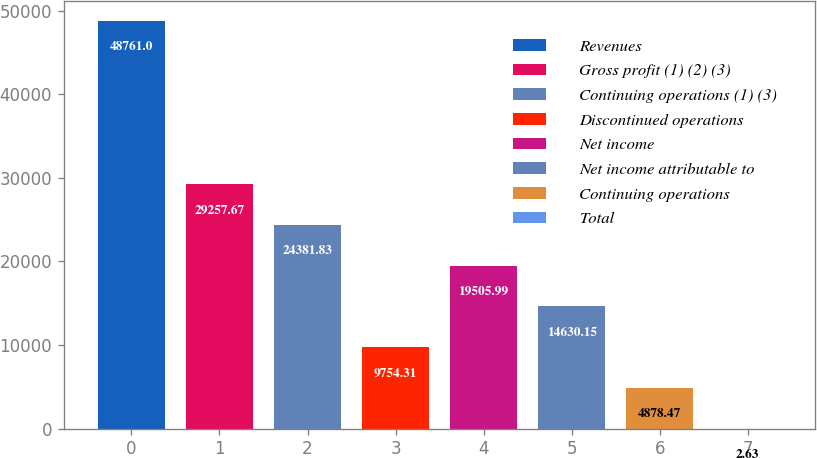<chart> <loc_0><loc_0><loc_500><loc_500><bar_chart><fcel>Revenues<fcel>Gross profit (1) (2) (3)<fcel>Continuing operations (1) (3)<fcel>Discontinued operations<fcel>Net income<fcel>Net income attributable to<fcel>Continuing operations<fcel>Total<nl><fcel>48761<fcel>29257.7<fcel>24381.8<fcel>9754.31<fcel>19506<fcel>14630.1<fcel>4878.47<fcel>2.63<nl></chart> 